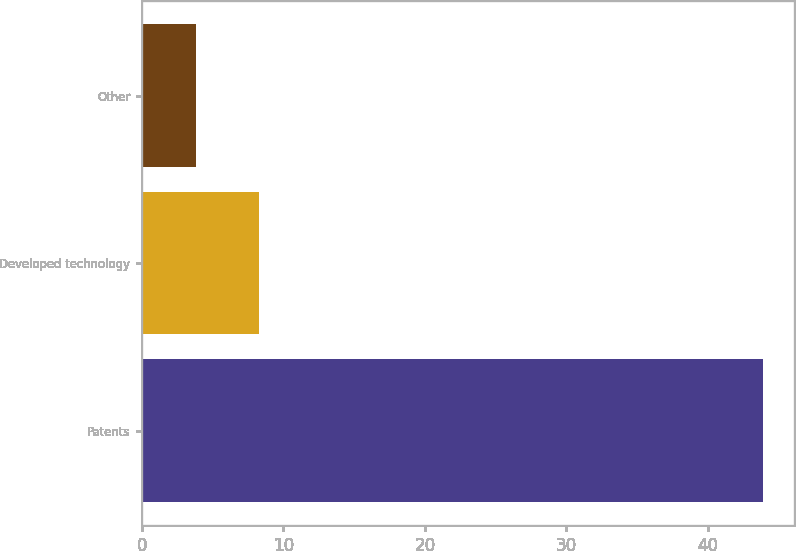Convert chart. <chart><loc_0><loc_0><loc_500><loc_500><bar_chart><fcel>Patents<fcel>Developed technology<fcel>Other<nl><fcel>43.9<fcel>8.3<fcel>3.8<nl></chart> 